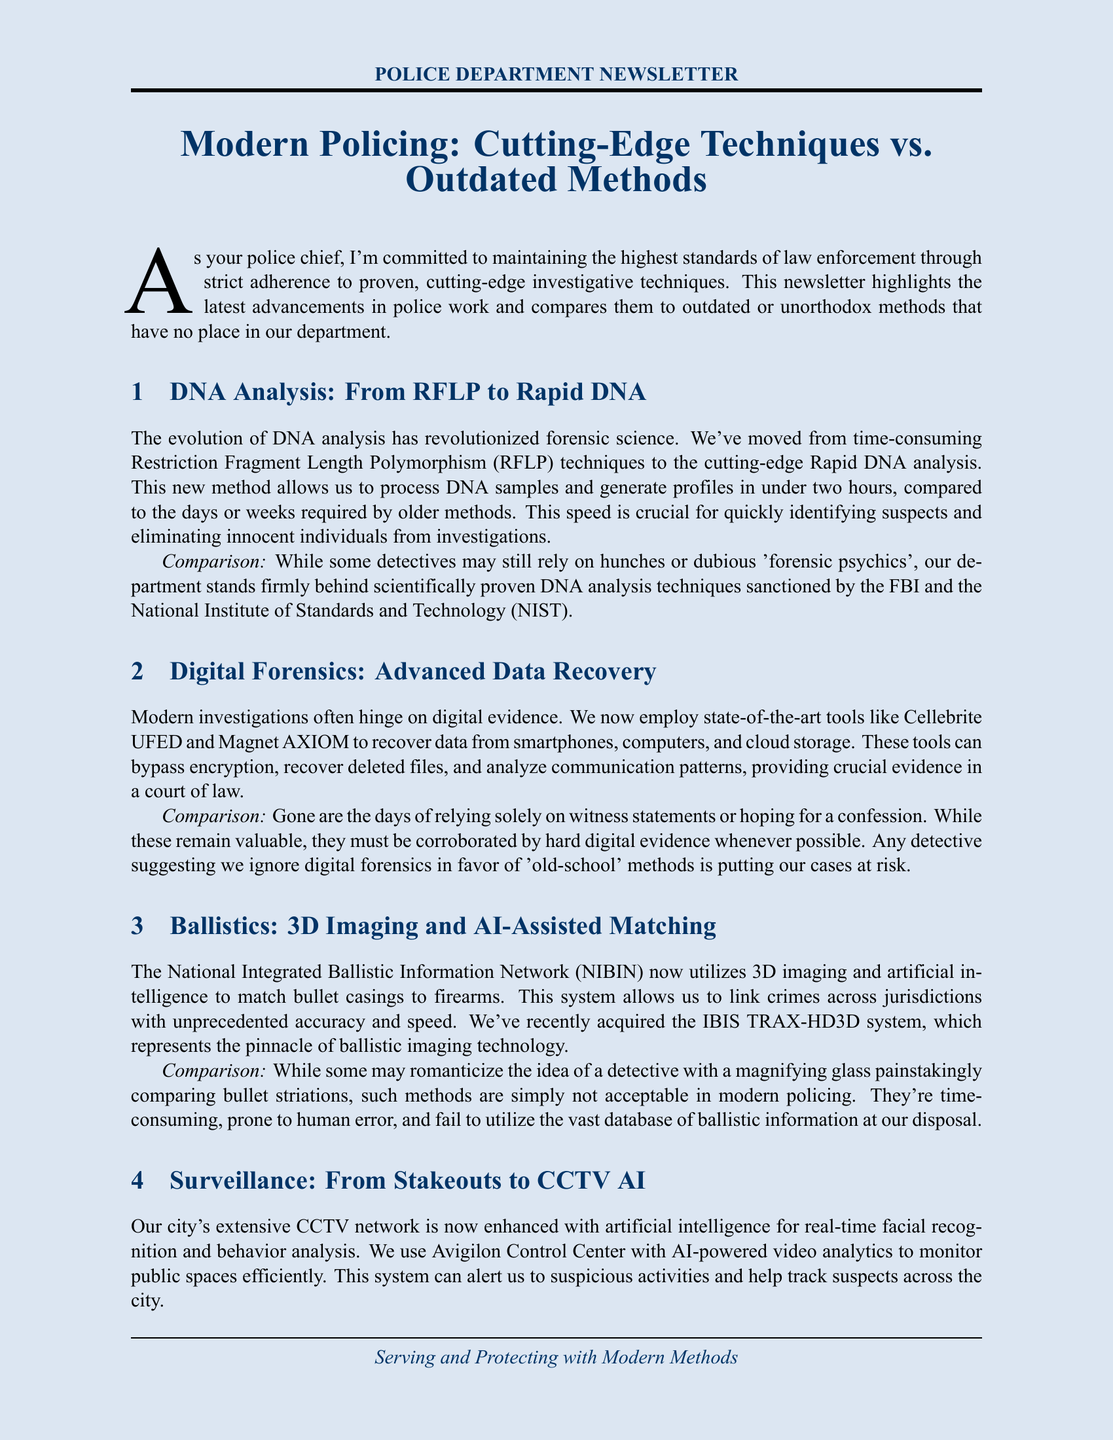What is the title of the newsletter? The title of the newsletter is prominently mentioned at the beginning, stating the focus on modern policing techniques.
Answer: Modern Policing: Cutting-Edge Techniques vs. Outdated Methods What technique improves witness recall by 40%? The newsletter discusses a specific interviewing technique that enhances recall, as proven by research.
Answer: Cognitive Interview What is the name of the AI-powered video analytics system used for surveillance? The document specifies the name of the advanced surveillance system utilized in the police department.
Answer: Avigilon Control Center What is the main advantage of Rapid DNA analysis over older techniques? The document highlights a significant benefit of Rapid DNA analysis compared to traditional methods regarding processing time.
Answer: Under two hours What outdated method is compared to advanced ballistics techniques? The newsletter contrasts modern ballistic technology against a specific, traditional forensic method.
Answer: Detective with a magnifying glass What type of tools are used for modern digital forensics? The document lists state-of-the-art tools that are employed for data recovery in current investigations.
Answer: Cellebrite UFED and Magnet AXIOM What is strictly prohibited during interviews with suspects? The document emphasizes a specific approach that is not allowed in interrogating suspects, indicating ethical standards.
Answer: Aggressive interrogation tactics What does the department require for dealing with digital evidence? The newsletter states a critical requirement to support the use of digital evidence in investigations.
Answer: Corroboration by hard digital evidence 